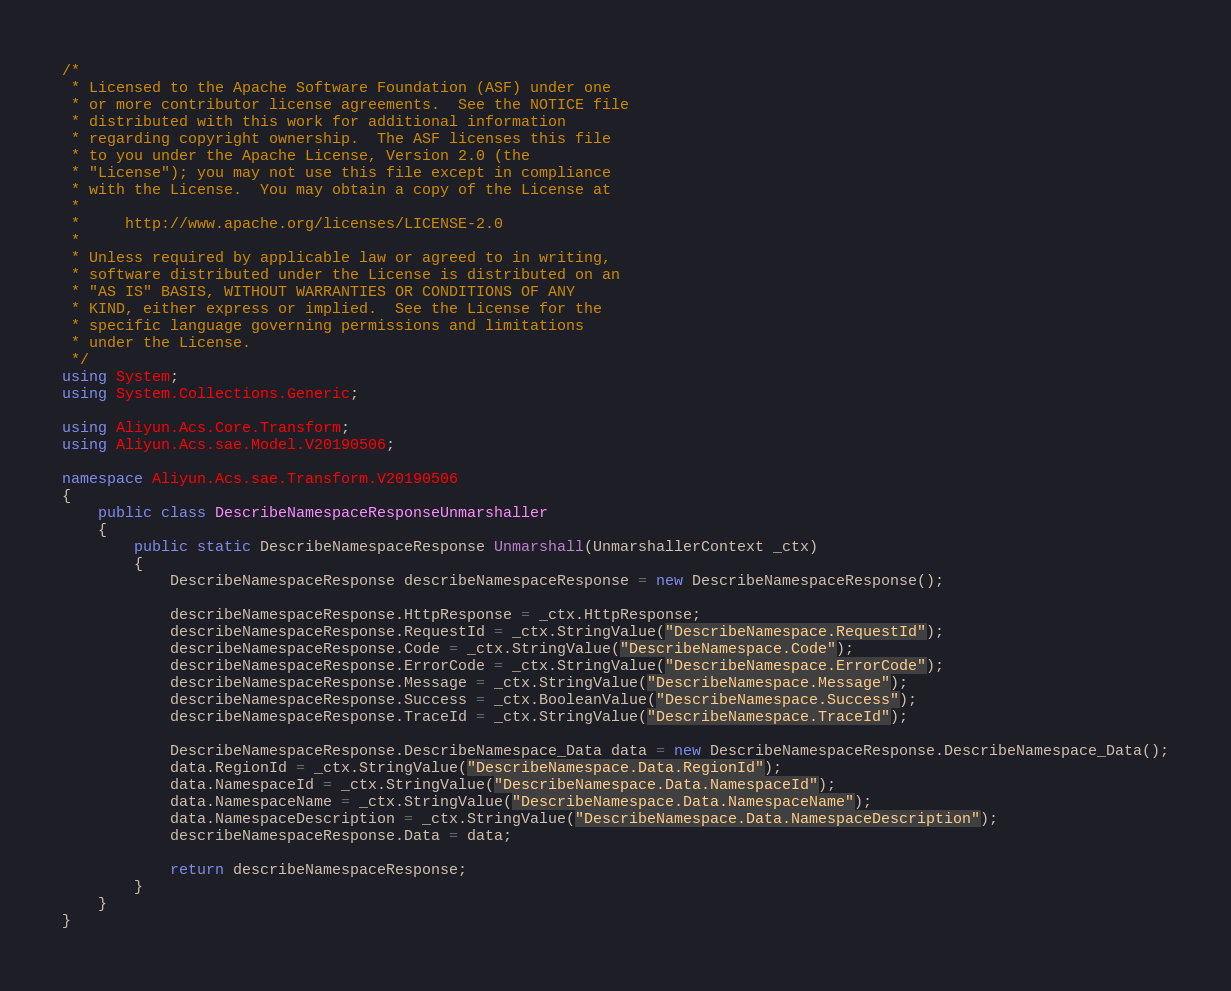Convert code to text. <code><loc_0><loc_0><loc_500><loc_500><_C#_>/*
 * Licensed to the Apache Software Foundation (ASF) under one
 * or more contributor license agreements.  See the NOTICE file
 * distributed with this work for additional information
 * regarding copyright ownership.  The ASF licenses this file
 * to you under the Apache License, Version 2.0 (the
 * "License"); you may not use this file except in compliance
 * with the License.  You may obtain a copy of the License at
 *
 *     http://www.apache.org/licenses/LICENSE-2.0
 *
 * Unless required by applicable law or agreed to in writing,
 * software distributed under the License is distributed on an
 * "AS IS" BASIS, WITHOUT WARRANTIES OR CONDITIONS OF ANY
 * KIND, either express or implied.  See the License for the
 * specific language governing permissions and limitations
 * under the License.
 */
using System;
using System.Collections.Generic;

using Aliyun.Acs.Core.Transform;
using Aliyun.Acs.sae.Model.V20190506;

namespace Aliyun.Acs.sae.Transform.V20190506
{
    public class DescribeNamespaceResponseUnmarshaller
    {
        public static DescribeNamespaceResponse Unmarshall(UnmarshallerContext _ctx)
        {
			DescribeNamespaceResponse describeNamespaceResponse = new DescribeNamespaceResponse();

			describeNamespaceResponse.HttpResponse = _ctx.HttpResponse;
			describeNamespaceResponse.RequestId = _ctx.StringValue("DescribeNamespace.RequestId");
			describeNamespaceResponse.Code = _ctx.StringValue("DescribeNamespace.Code");
			describeNamespaceResponse.ErrorCode = _ctx.StringValue("DescribeNamespace.ErrorCode");
			describeNamespaceResponse.Message = _ctx.StringValue("DescribeNamespace.Message");
			describeNamespaceResponse.Success = _ctx.BooleanValue("DescribeNamespace.Success");
			describeNamespaceResponse.TraceId = _ctx.StringValue("DescribeNamespace.TraceId");

			DescribeNamespaceResponse.DescribeNamespace_Data data = new DescribeNamespaceResponse.DescribeNamespace_Data();
			data.RegionId = _ctx.StringValue("DescribeNamespace.Data.RegionId");
			data.NamespaceId = _ctx.StringValue("DescribeNamespace.Data.NamespaceId");
			data.NamespaceName = _ctx.StringValue("DescribeNamespace.Data.NamespaceName");
			data.NamespaceDescription = _ctx.StringValue("DescribeNamespace.Data.NamespaceDescription");
			describeNamespaceResponse.Data = data;
        
			return describeNamespaceResponse;
        }
    }
}
</code> 